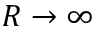<formula> <loc_0><loc_0><loc_500><loc_500>R \to \infty</formula> 